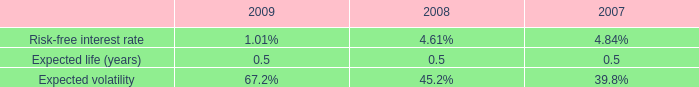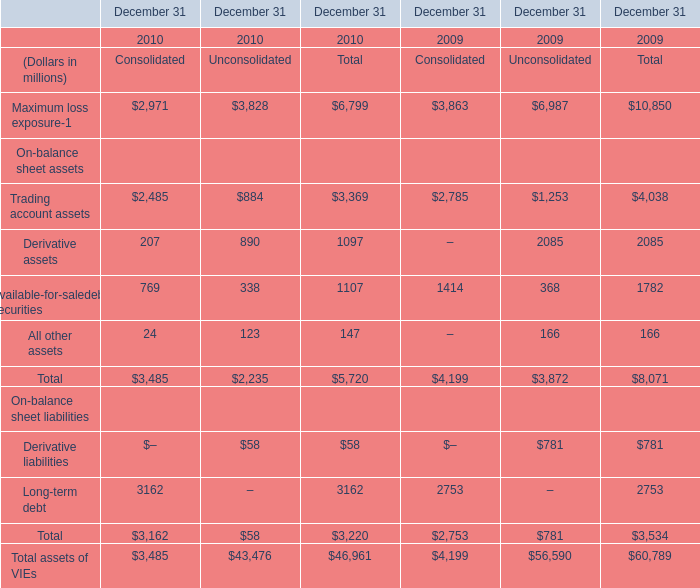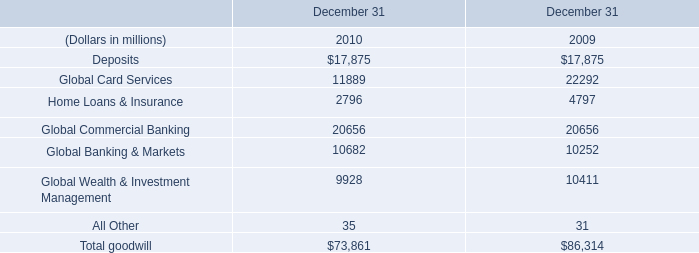What is the average amount of Global Card Services of December 31 2009, and Maximum loss exposure of December 31 2009 Unconsolidated ? 
Computations: ((22292.0 + 6987.0) / 2)
Answer: 14639.5. 